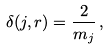Convert formula to latex. <formula><loc_0><loc_0><loc_500><loc_500>\delta ( j , r ) = \frac { 2 } { m _ { j } } \, ,</formula> 